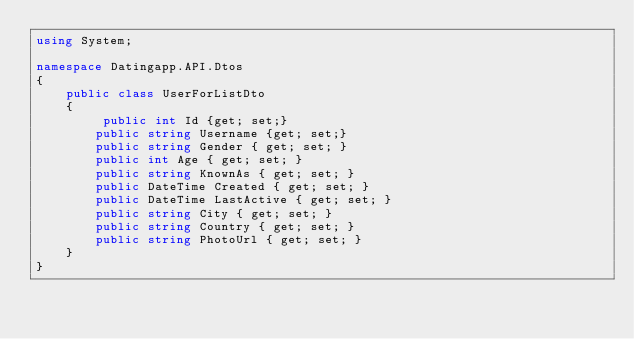<code> <loc_0><loc_0><loc_500><loc_500><_C#_>using System;

namespace Datingapp.API.Dtos
{
    public class UserForListDto
    {
         public int Id {get; set;}
        public string Username {get; set;}
        public string Gender { get; set; }
        public int Age { get; set; }
        public string KnownAs { get; set; }
        public DateTime Created { get; set; }
        public DateTime LastActive { get; set; }
        public string City { get; set; }
        public string Country { get; set; }
        public string PhotoUrl { get; set; } 
    }
}</code> 